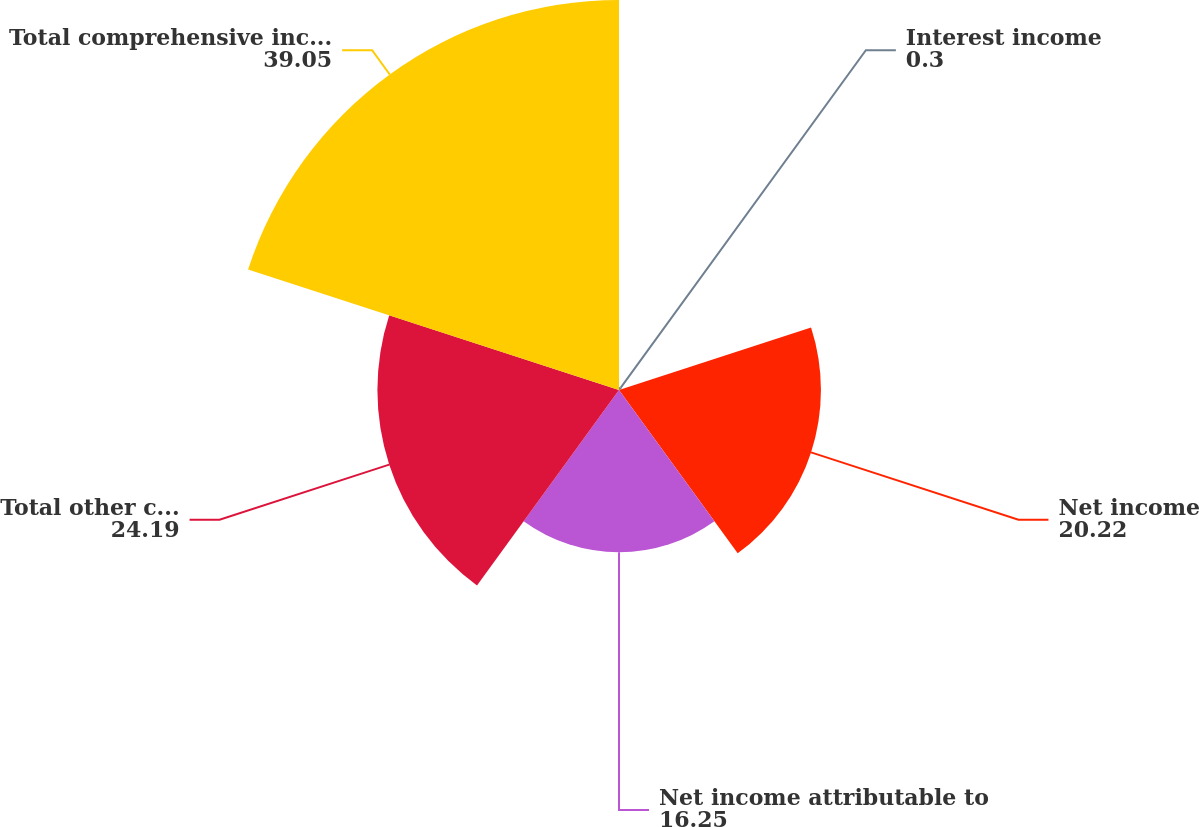<chart> <loc_0><loc_0><loc_500><loc_500><pie_chart><fcel>Interest income<fcel>Net income<fcel>Net income attributable to<fcel>Total other comprehensive<fcel>Total comprehensive income<nl><fcel>0.3%<fcel>20.22%<fcel>16.25%<fcel>24.19%<fcel>39.05%<nl></chart> 